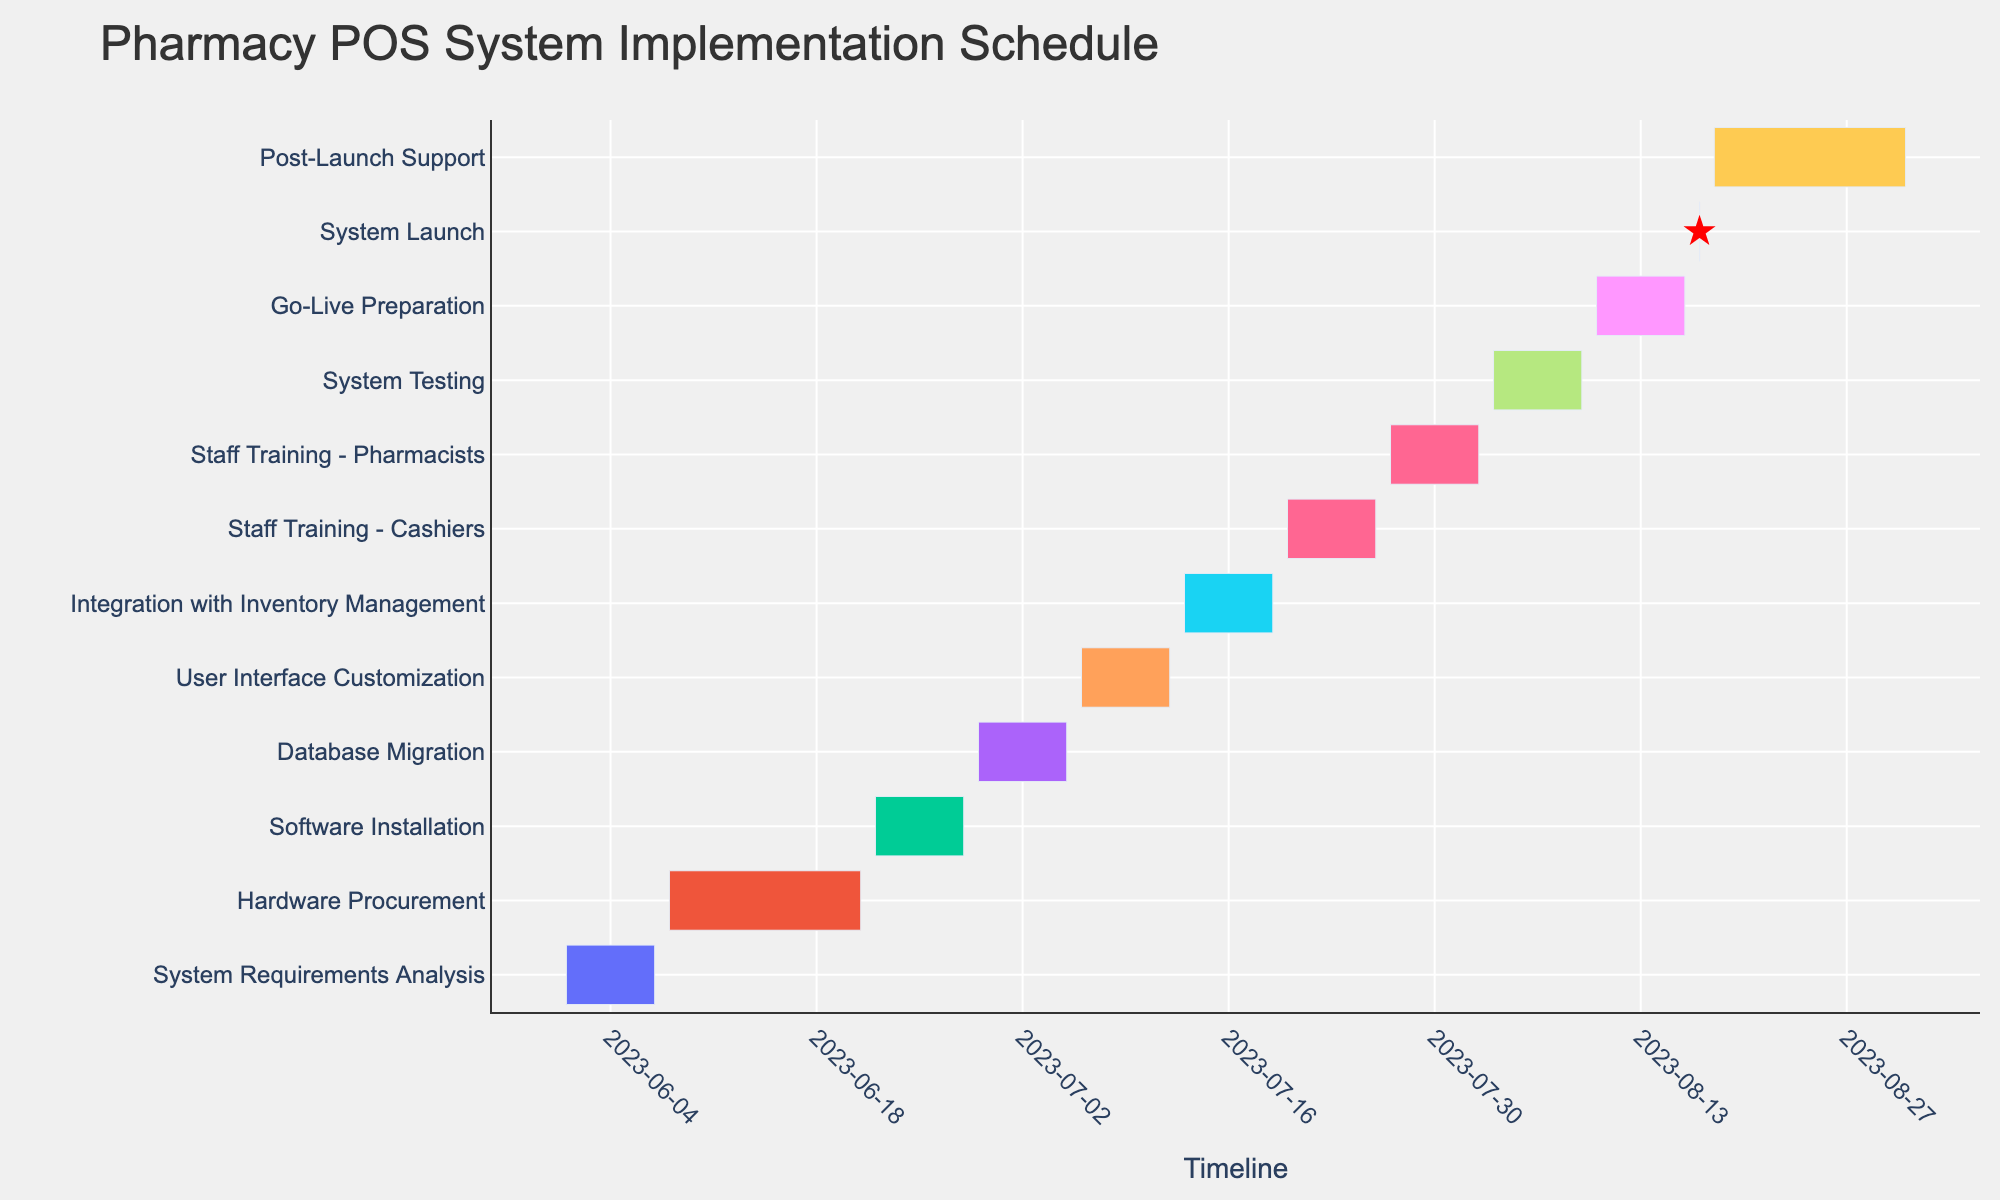What is the title of the Gantt Chart? The title is usually found at the top of the figure, indicating the main topic or purpose of the chart. In this case, it describes the project schedule for implementing a new point-of-sale system in the pharmacy.
Answer: Pharmacy POS System Implementation Schedule What is the duration of the Hardware Procurement task? Look for the Hardware Procurement task in the y-axis, then check its duration, which should be either marked or retrievable from the length of the task bar or annotations provided.
Answer: 14 days Which task appears to have the shortest duration? Identify the task bars that are the shortest along the x-axis, which usually represent the shortest duration. Check the labels to confirm the specific task.
Answer: System Launch How long is the entire project period, from the start of the first task to the end of the last task? Note the start date of the first task (System Requirements Analysis) and the end date of the last task (Post-Launch Support), then calculate the difference between these two dates.
Answer: 92 days Which tasks are directly associated with staff training? Scan the y-axis for any tasks with "Staff Training" in their name, and list them. There are usually two distinct task bars for training.
Answer: Staff Training - Cashiers, Staff Training - Pharmacists What is the duration of the task following "Database Migration"? Locate the Database Migration task on the y-axis, then find the task immediately below it and check its duration. In this instance, the next task should be User Interface Customization.
Answer: 7 days Which task takes place immediately before the Go-Live Preparation? Find the Go-Live Preparation task on the y-axis, then identify the task directly above it in the schedule.
Answer: System Testing How many tasks have a duration of exactly 7 days? Count the number of task bars which span exactly 7 days along the x-axis.
Answer: 9 tasks What color represents the User Interface Customization task, and what might that suggest about its category? Identify the User Interface Customization task on the y-axis, then note its color, and cross-reference this with the color legend to infer the category it belongs to.
Answer: Pink, Customization If we grouped all the training tasks together, what would be their combined duration? Sum the durations of Staff Training - Cashiers and Staff Training - Pharmacists. Each task spans exactly 7 days.
Answer: 14 days 